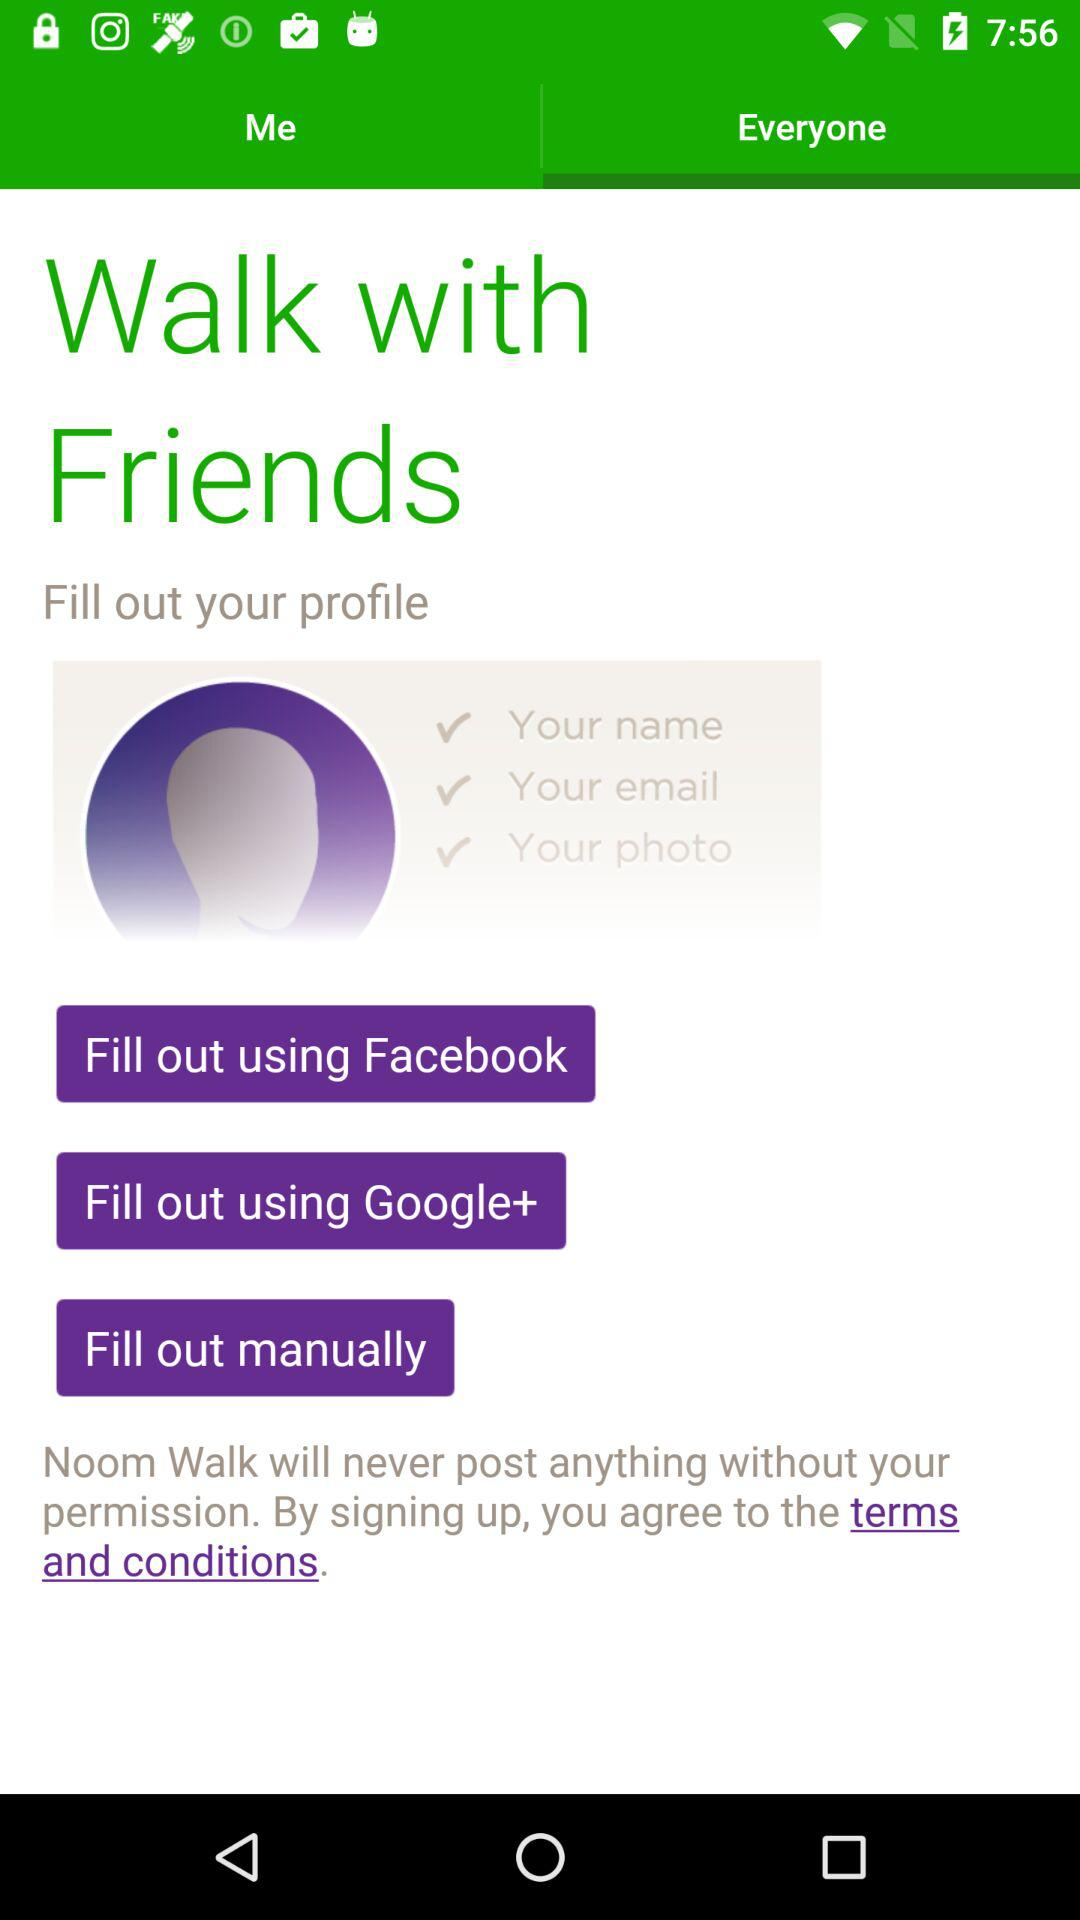What accounts can be used to fill out the user profile? The accounts that can be used are "Facebook" and "Google+". 